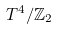<formula> <loc_0><loc_0><loc_500><loc_500>T ^ { 4 } / \mathbb { Z } _ { 2 }</formula> 